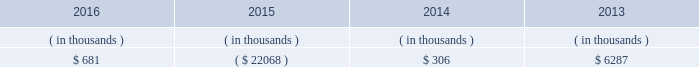Entergy texas , inc .
And subsidiaries management 2019s financial discussion and analysis in addition to the contractual obligations given above , entergy texas expects to contribute approximately $ 17 million to its qualified pension plans and approximately $ 3.2 million to other postretirement health care and life insurance plans in 2017 , although the 2017 required pension contributions will be known with more certainty when the january 1 , 2017 valuations are completed , which is expected by april 1 , 2017 .
See 201ccritical accounting estimates - qualified pension and other postretirement benefits 201d below for a discussion of qualified pension and other postretirement benefits funding .
Also in addition to the contractual obligations , entergy texas has $ 15.6 million of unrecognized tax benefits and interest net of unused tax attributes and payments for which the timing of payments beyond 12 months cannot be reasonably estimated due to uncertainties in the timing of effective settlement of tax positions .
See note 3 to the financial statements for additional information regarding unrecognized tax benefits .
In addition to routine capital spending to maintain operations , the planned capital investment estimate for entergy texas includes specific investments such as the montgomery county power station discussed below ; transmission projects to enhance reliability , reduce congestion , and enable economic growth ; distribution spending to enhance reliability and improve service to customers , including initial investment to support advanced metering ; system improvements ; and other investments .
Estimated capital expenditures are subject to periodic review and modification and may vary based on the ongoing effects of regulatory constraints and requirements , environmental compliance , business opportunities , market volatility , economic trends , business restructuring , changes in project plans , and the ability to access capital .
Management provides more information on long-term debt in note 5 to the financial statements .
As discussed above in 201ccapital structure , 201d entergy texas routinely evaluates its ability to pay dividends to entergy corporation from its earnings .
Sources of capital entergy texas 2019s sources to meet its capital requirements include : 2022 internally generated funds ; 2022 cash on hand ; 2022 debt or preferred stock issuances ; and 2022 bank financing under new or existing facilities .
Entergy texas may refinance , redeem , or otherwise retire debt prior to maturity , to the extent market conditions and interest and dividend rates are favorable .
All debt and common and preferred stock issuances by entergy texas require prior regulatory approval .
Debt issuances are also subject to issuance tests set forth in its bond indenture and other agreements .
Entergy texas has sufficient capacity under these tests to meet its foreseeable capital needs .
Entergy texas 2019s receivables from or ( payables to ) the money pool were as follows as of december 31 for each of the following years. .
See note 4 to the financial statements for a description of the money pool .
Entergy texas has a credit facility in the amount of $ 150 million scheduled to expire in august 2021 .
The credit facility allows entergy texas to issue letters of credit against 50% ( 50 % ) of the borrowing capacity of the facility .
As of december 31 , 2016 , there were no cash borrowings and $ 4.7 million of letters of credit outstanding under the credit facility .
In addition , entergy texas is a party to an uncommitted letter of credit facility as a means to post collateral .
As of december 31 , 2016 , what percentage of the august 2021 credit facility was drawn? 
Computations: (4.7 / 150)
Answer: 0.03133. 